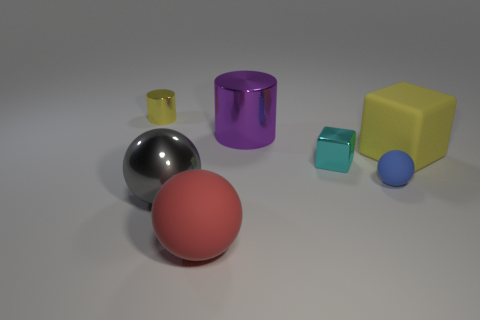Add 3 metal balls. How many objects exist? 10 Subtract all spheres. How many objects are left? 4 Add 4 tiny red shiny cylinders. How many tiny red shiny cylinders exist? 4 Subtract 0 blue cylinders. How many objects are left? 7 Subtract all small cylinders. Subtract all big red objects. How many objects are left? 5 Add 5 cyan things. How many cyan things are left? 6 